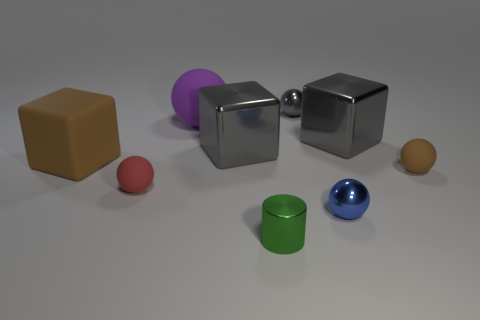What number of red shiny things are the same size as the gray ball? In the image, there are no red shiny objects that are the same size as the gray ball. The gray ball is unique in size compared to the red object, which is larger. 